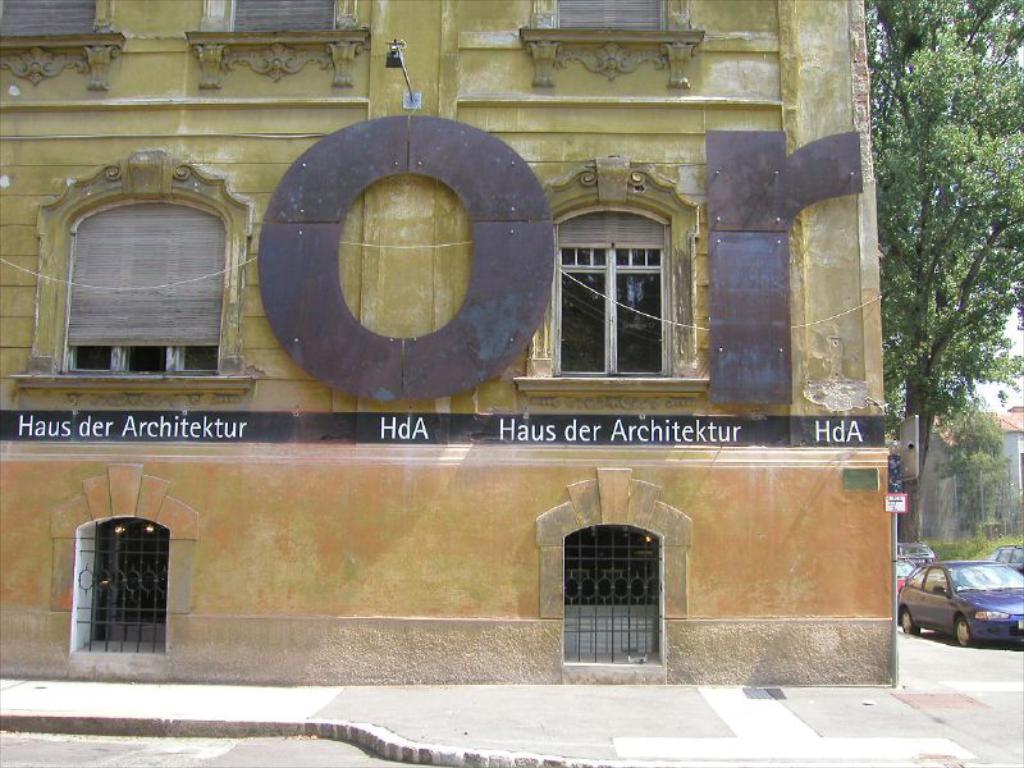Could you give a brief overview of what you see in this image? This image consists of a building along with the windows. In the front, there is a text on the wall. At the bottom, we can see pavement and a road. On the right, there are cars along with the trees. And there is a house. 